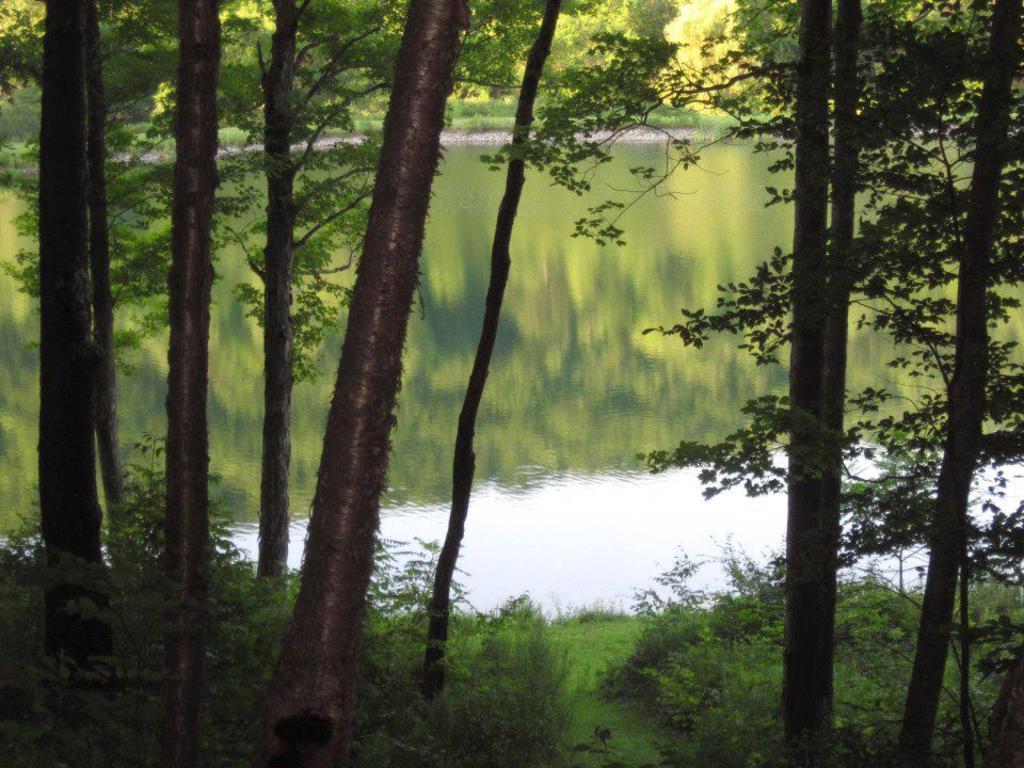Can you describe this image briefly? In this image I can see trees, plants and the grass. In the background I can see water. 